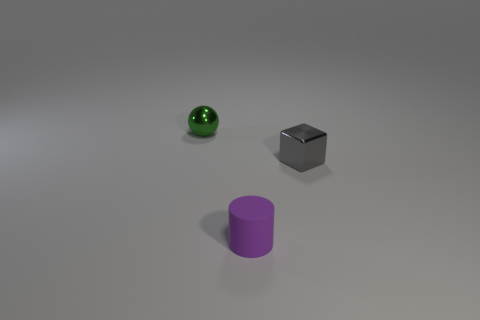Subtract all cubes. How many objects are left? 2 Add 2 tiny purple matte things. How many objects exist? 5 Subtract all gray cylinders. Subtract all purple balls. How many cylinders are left? 1 Subtract all rubber things. Subtract all purple rubber cylinders. How many objects are left? 1 Add 2 metal spheres. How many metal spheres are left? 3 Add 1 green matte cylinders. How many green matte cylinders exist? 1 Subtract 0 blue balls. How many objects are left? 3 Subtract 1 spheres. How many spheres are left? 0 